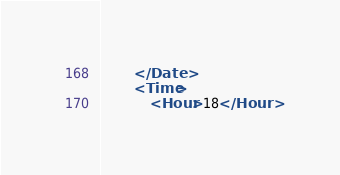<code> <loc_0><loc_0><loc_500><loc_500><_XML_>		</Date>
		<Time>
			<Hour>18</Hour></code> 